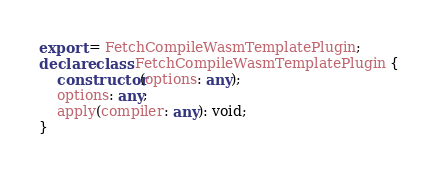<code> <loc_0><loc_0><loc_500><loc_500><_TypeScript_>export = FetchCompileWasmTemplatePlugin;
declare class FetchCompileWasmTemplatePlugin {
    constructor(options: any);
    options: any;
    apply(compiler: any): void;
}
</code> 